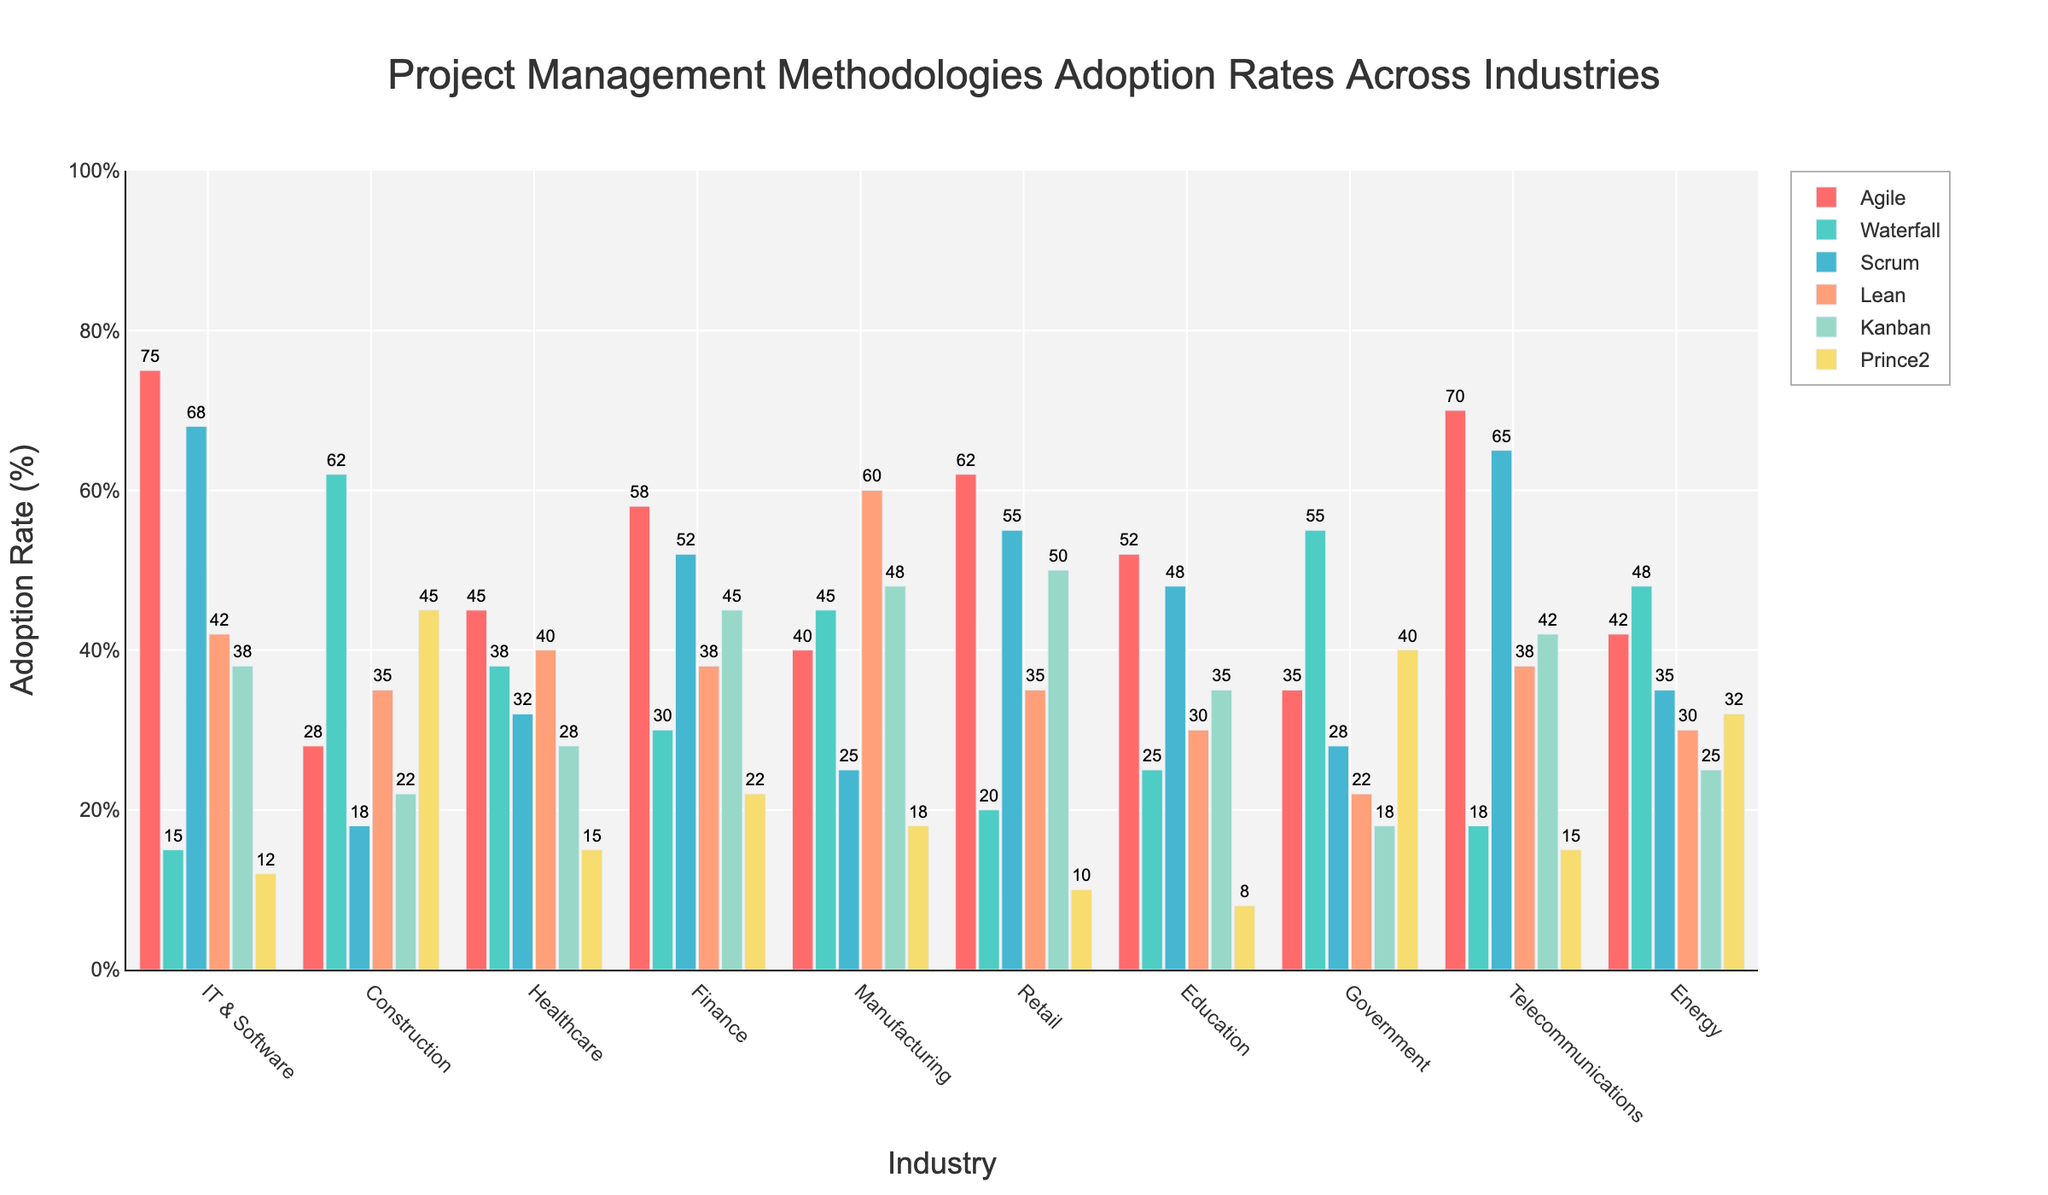Which industry has the highest adoption rate of Agile methodology? By visually inspecting the bars for Agile methodology across industries, the tallest bar represents the highest adoption rate. The IT & Software industry has the highest Agile adoption rate with 75%.
Answer: IT & Software Between the Finance and Energy industries, which has a higher adoption rate for the Scrum methodology? By comparing the heights of the Scrum methodology bars for the Finance and Energy industries, the Finance industry has a taller bar at 52% compared to 35% for the Energy industry.
Answer: Finance What is the total adoption rate for Kanban and Lean methodologies in the Manufacturing industry? Adding the adoption rates of Kanban (48%) and Lean (60%) methodologies in the Manufacturing industry gives us the total: 48 + 60 = 108.
Answer: 108 Which industry has the lowest adoption rate of Prince2 methodology? By visually inspecting the bars for Prince2 methodology across industries, the shortest bar represents the lowest adoption rate. The Retail industry has the lowest Prince2 adoption rate at 10%.
Answer: Retail Compare the adoption rates of Waterfall and Agile methodologies in the Government industry. Which is higher, and by how much? The Government industry has a 55% adoption rate for Waterfall methodology and a 35% adoption rate for Agile methodology. The difference is: 55 - 35 = 20.
Answer: Waterfall by 20% What is the average adoption rate of Agile methodology across all industries? Adding the adoption rates of Agile methodology across all industries and dividing by the number of industries (10) gives us: (75 + 28 + 45 + 58 + 40 + 62 + 52 + 35 + 70 + 42) / 10 = 50.7.
Answer: 50.7 How does the adoption rate of Lean methodology in IT & Software compare to that in Healthcare? The IT & Software industry has a 42% adoption rate for Lean methodology, whereas Healthcare has a 40% adoption rate. Thus, IT & Software has a slightly higher adoption rate by 2%.
Answer: IT & Software by 2% Which two industries have the highest combined adoption rate of Scrum methodology? By inspecting the bars for Scrum methodology across industries and summing the top two, IT & Software (68%) and Telecommunications (65%) have the highest combined adoption rate: 68 + 65 = 133.
Answer: IT & Software and Telecommunications If the average adoption rate of methodologies for the Education industry is needed, what would it be? Adding the adoption rates for all methodologies in the Education industry and dividing by the number of methodologies (6) gives us: (52 + 25 + 48 + 30 + 35 + 8) / 6 = 33.
Answer: 33 What is the difference in adoption rates of Kanban methodology between the Retail and Energy industries? The Retail industry has a 50% adoption rate for Kanban methodology, whereas the Energy industry has a 25% adoption rate. The difference is: 50 - 25 = 25.
Answer: 25 